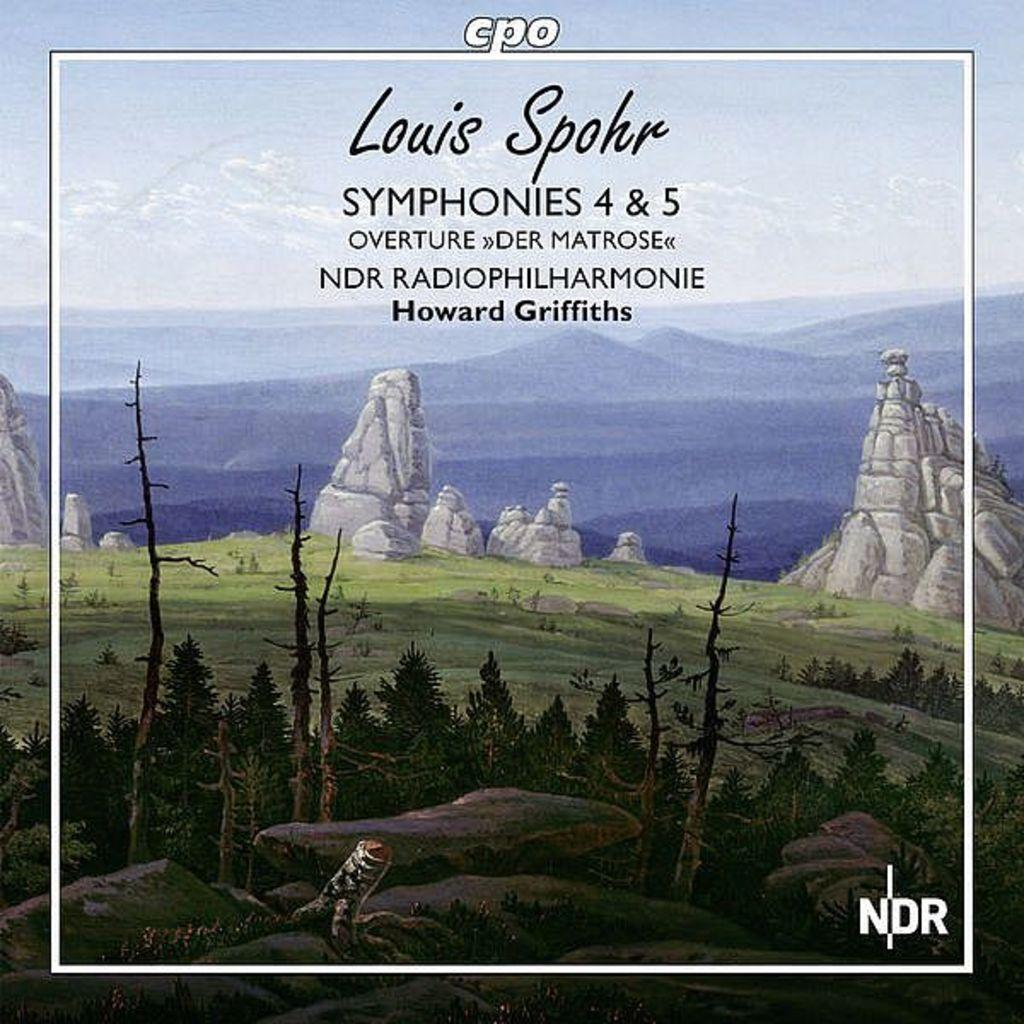What is featured on the poster in the image? There is a poster with text in the image. What type of natural elements can be seen in the image? There are trees and stones visible in the image. What can be seen in the background of the image? There are hills in the background of the image. What is visible at the top of the image? The sky is visible in the image. How many teeth can be seen on the poster in the image? There are no teeth visible on the poster in the image. What type of park is shown in the image? There is no park present in the image; it features a poster with text, trees, stones, hills, and the sky. 